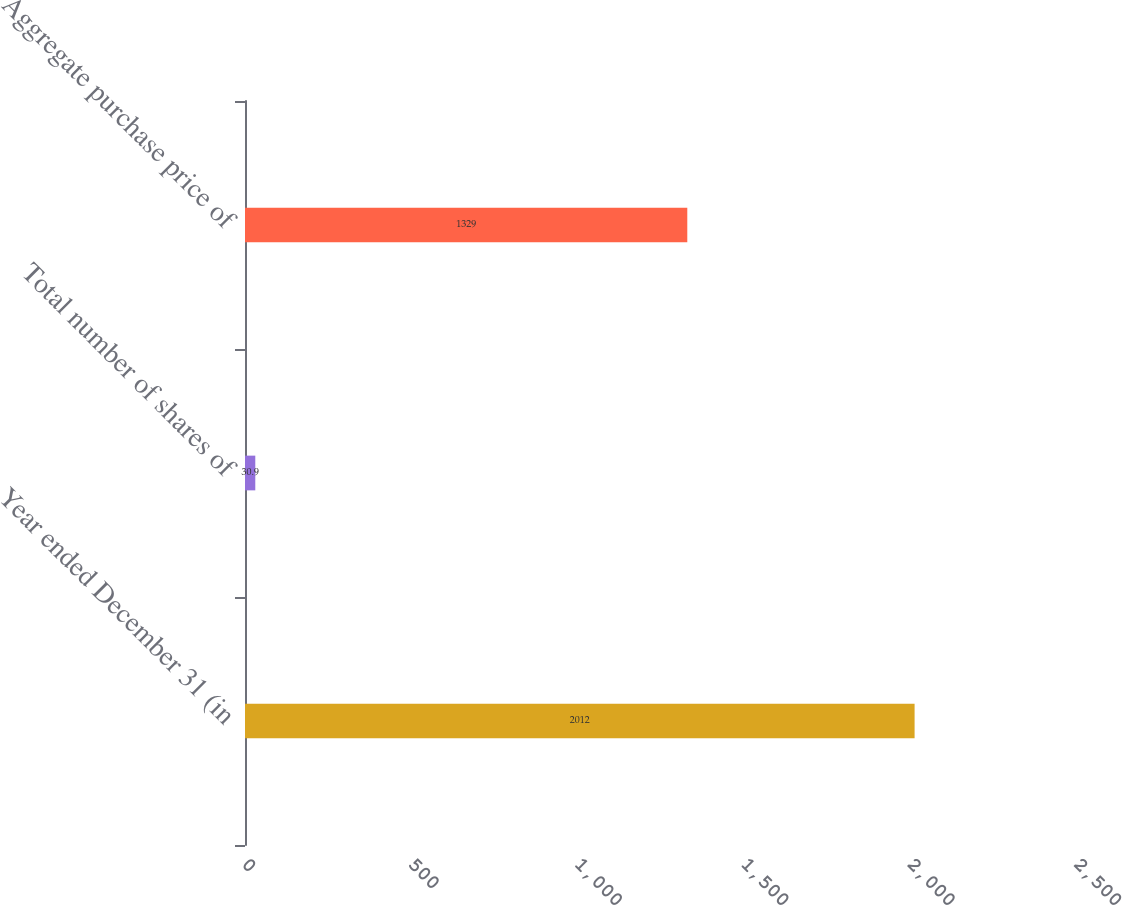Convert chart to OTSL. <chart><loc_0><loc_0><loc_500><loc_500><bar_chart><fcel>Year ended December 31 (in<fcel>Total number of shares of<fcel>Aggregate purchase price of<nl><fcel>2012<fcel>30.9<fcel>1329<nl></chart> 